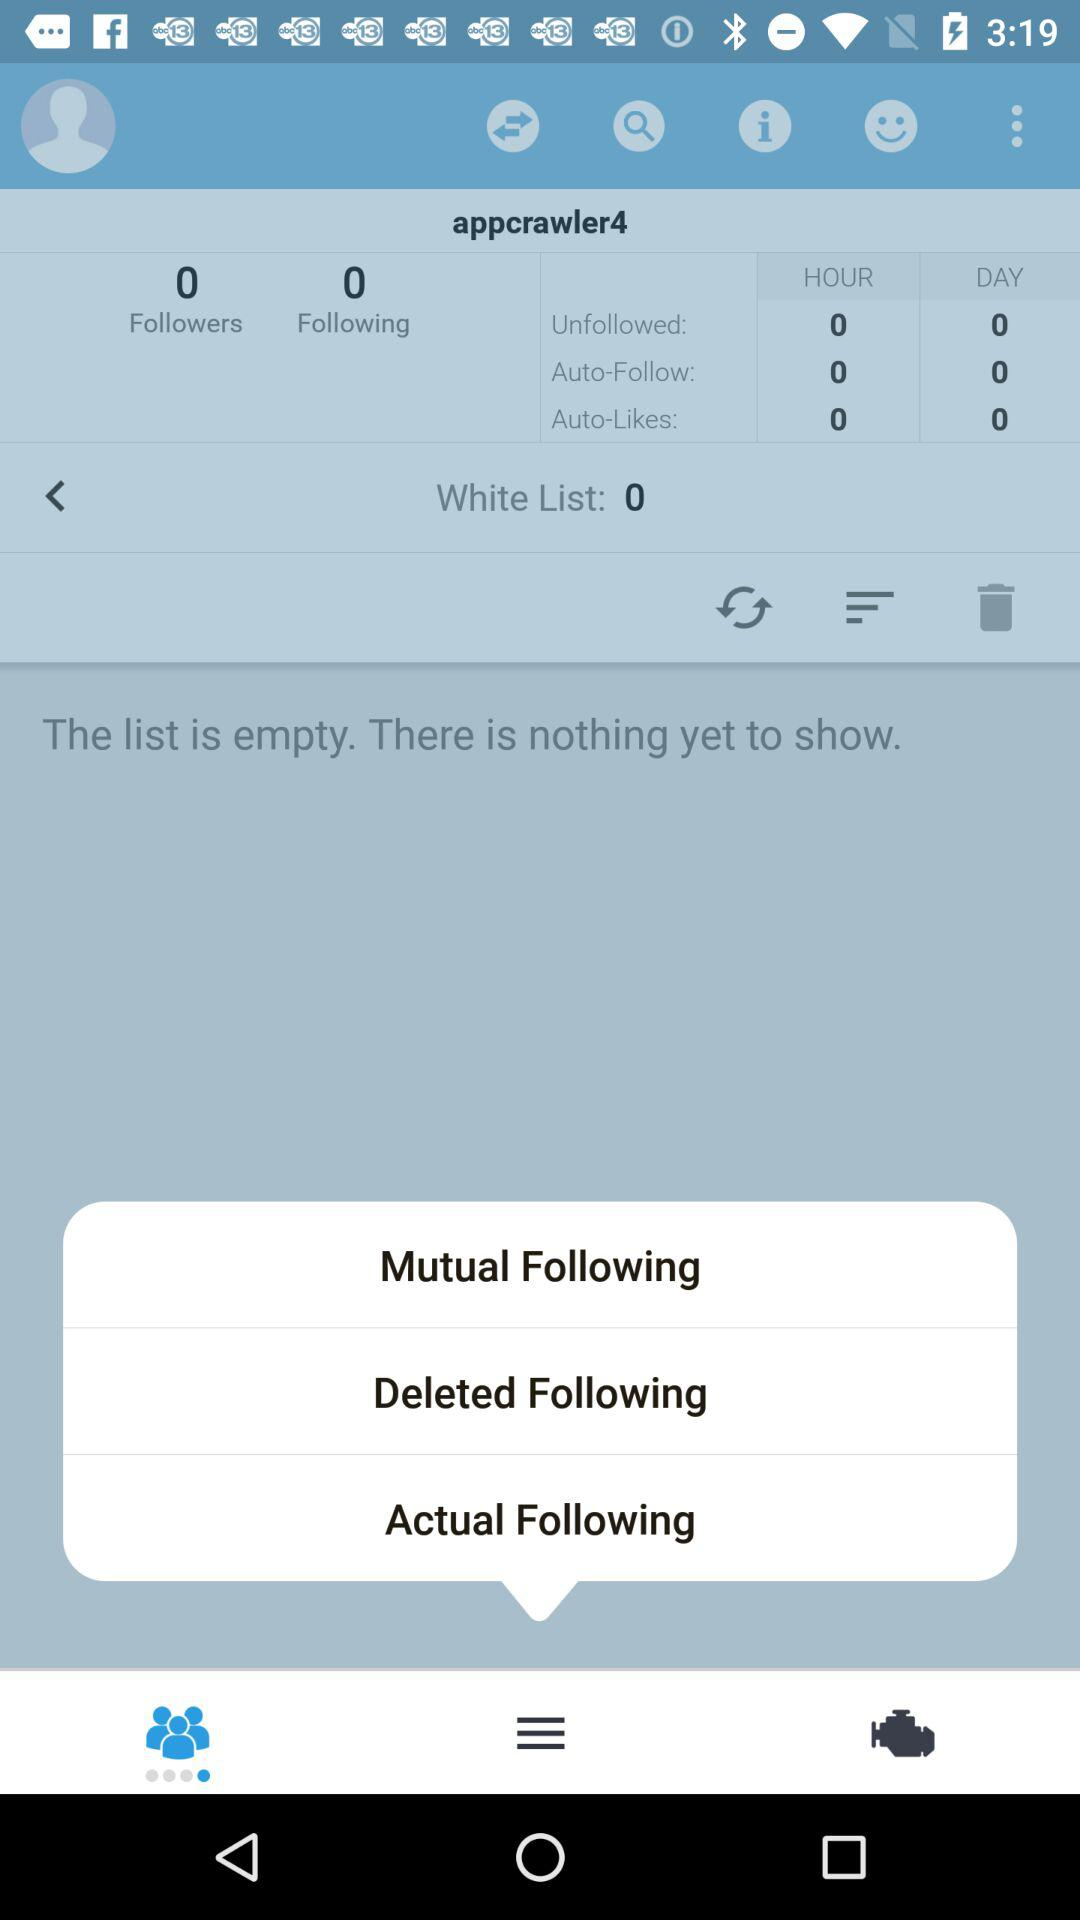How many people am I following? You are following 0 people. 